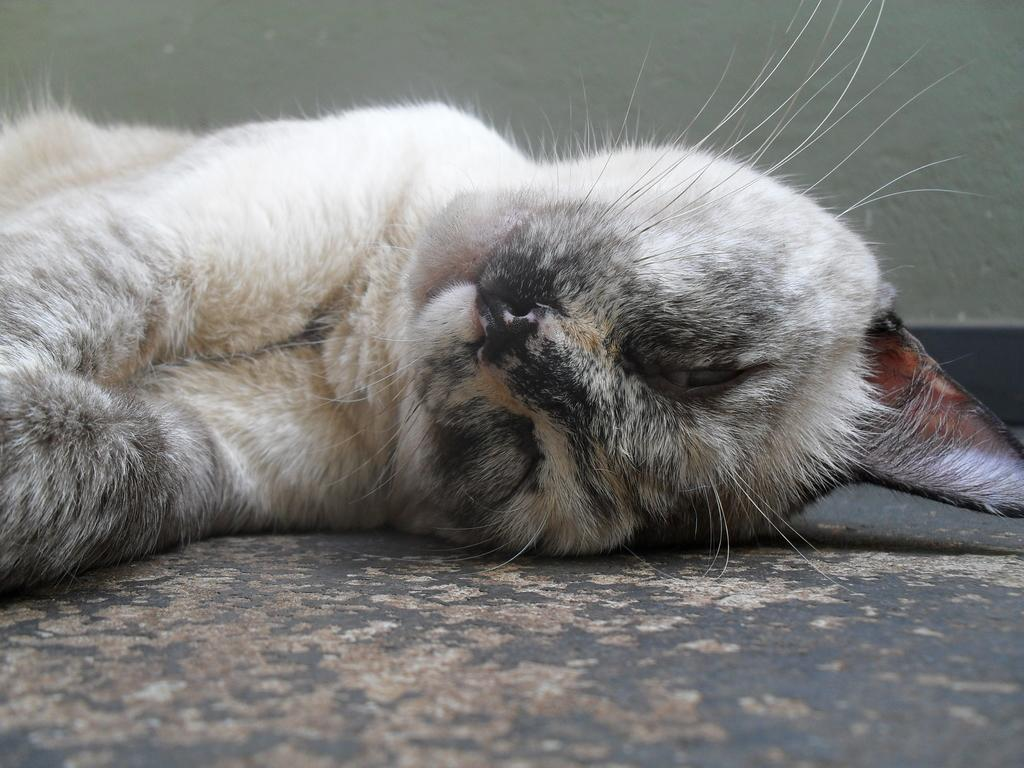What animal is present in the image? There is a cat in the image. Where is the cat located? The cat is on the floor. What can be seen in the background of the image? There is a wall in the background of the image. What word is the cat saying in the image? Cats do not have the ability to speak or say words, so there is no word being said by the cat in the image. 